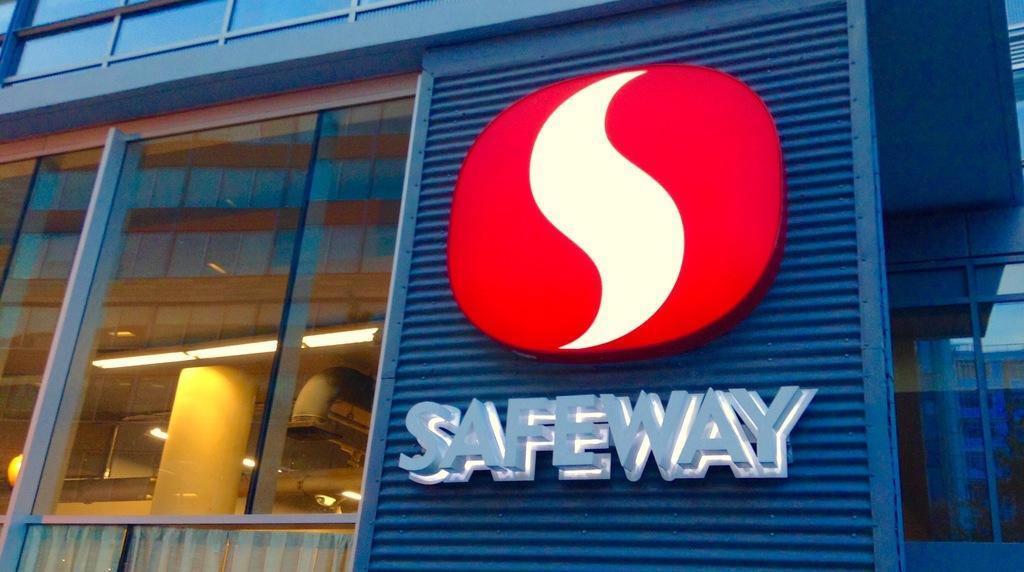Can you describe this image briefly? In this image we can see the building with logo and text. And we can see there are windows, through the windows we can see the pillar, lights and pipeline. And at the top we can see the ceiling with lights. 